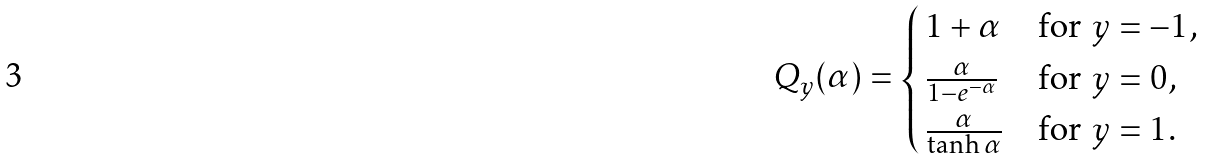Convert formula to latex. <formula><loc_0><loc_0><loc_500><loc_500>Q _ { y } ( \alpha ) = \begin{cases} \, 1 + \alpha & \text {for $y=-1$,} \\ \, \frac { \alpha } { 1 - e ^ { - \alpha } } & \text {for $y=0$,} \\ \, \frac { \alpha } { \tanh \alpha } & \text {for $y=1$.} \end{cases}</formula> 